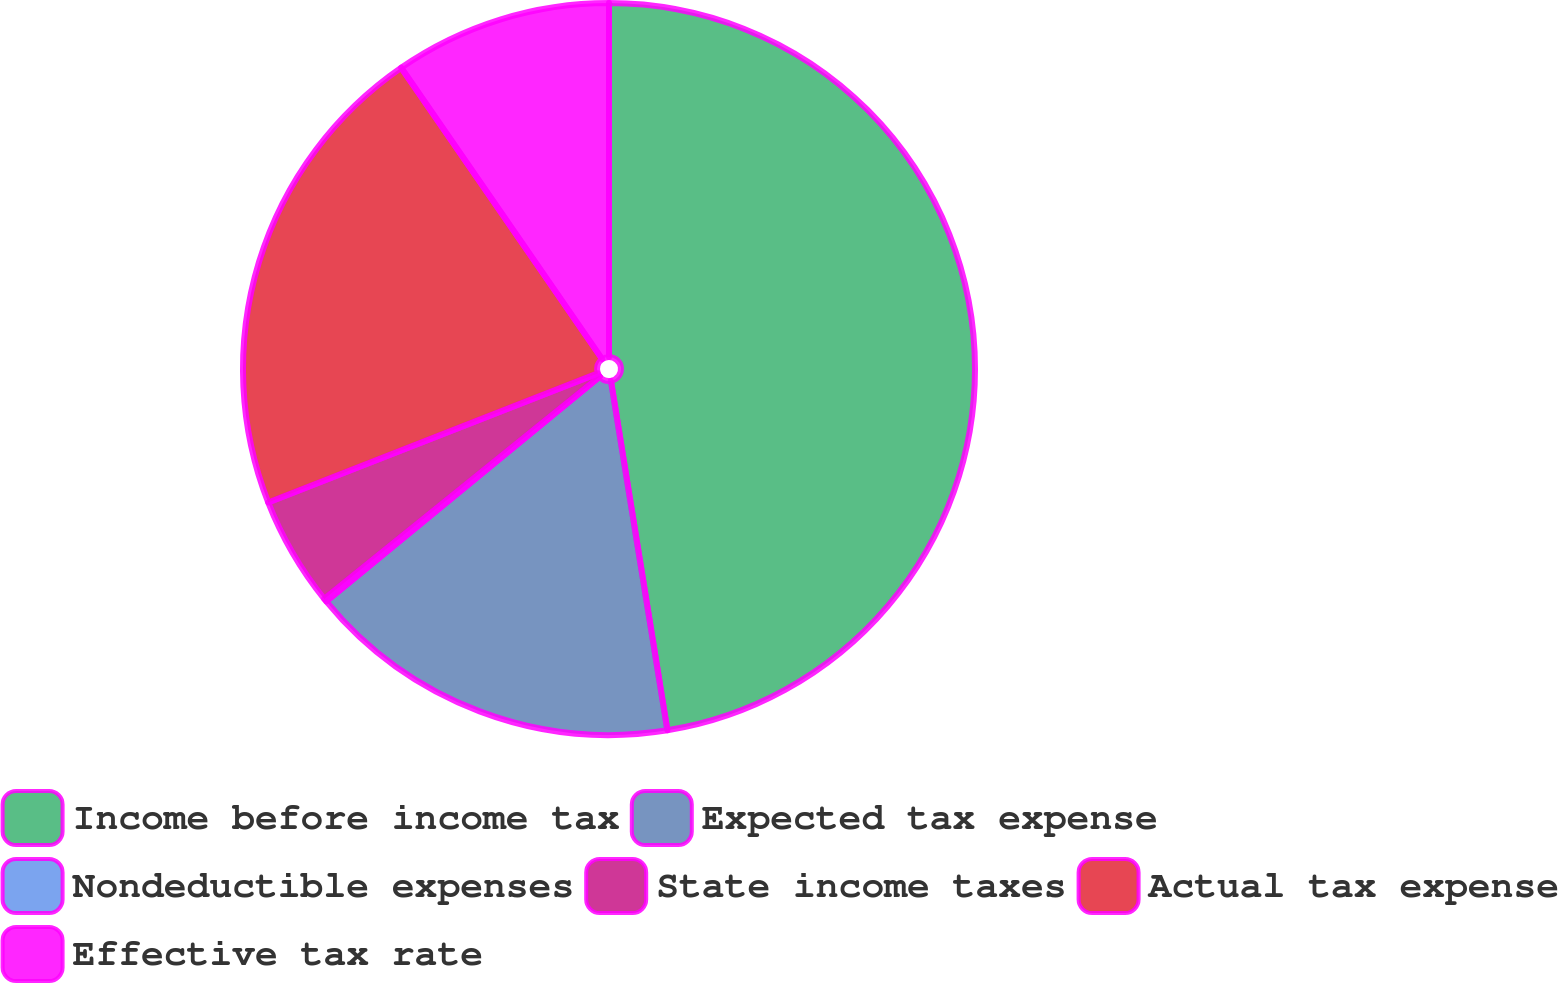Convert chart to OTSL. <chart><loc_0><loc_0><loc_500><loc_500><pie_chart><fcel>Income before income tax<fcel>Expected tax expense<fcel>Nondeductible expenses<fcel>State income taxes<fcel>Actual tax expense<fcel>Effective tax rate<nl><fcel>47.45%<fcel>16.6%<fcel>0.14%<fcel>4.87%<fcel>21.33%<fcel>9.61%<nl></chart> 